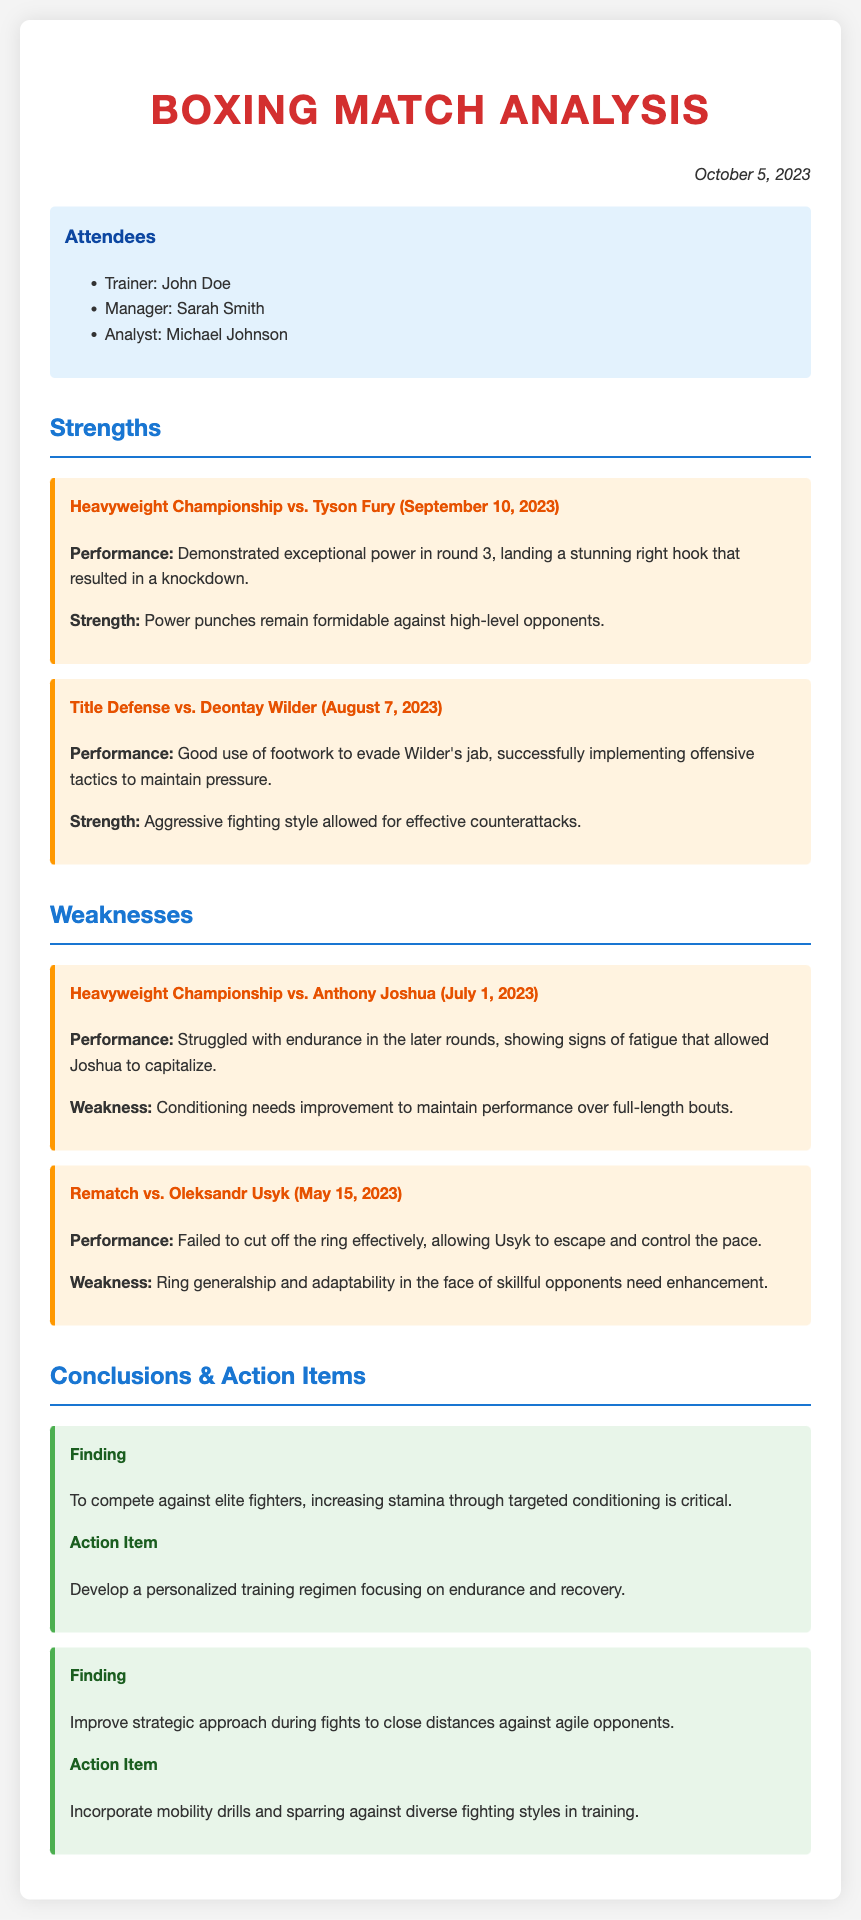What is the date of the meeting? The date listed in the meeting minutes is October 5, 2023.
Answer: October 5, 2023 Who demonstrated exceptional power in their match? The document states that the heavyweight boxer demonstrated exceptional power in the match against Tyson Fury.
Answer: Tyson Fury What was a strength in the match against Deontay Wilder? The minutes highlight the aggressive fighting style as a strength during the match against Deontay Wilder.
Answer: Aggressive fighting style What notable issue arose in the match against Anthony Joshua? The heavyweight boxer struggled with endurance in the later rounds during the match against Anthony Joshua.
Answer: Endurance What action item focuses on stamina? The action item concerning stamina involves developing a personalized training regimen focusing on endurance.
Answer: Personalized training regimen Which opponent required improvement in ring generalship? The rematch against Oleksandr Usyk emphasized the need for improvement in ring generalship according to the minutes.
Answer: Oleksandr Usyk What type of drills are suggested to improve strategy? The document suggests incorporating mobility drills in training to improve strategic approaches during fights.
Answer: Mobility drills Who was the trainer present at the meeting? John Doe is noted as the trainer who attended the meeting.
Answer: John Doe 